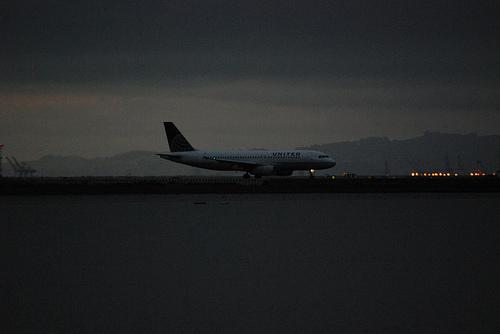Question: when airline is this?
Choices:
A. Delta.
B. United.
C. SouthWest.
D. AirTran.
Answer with the letter. Answer: B Question: where is the plane?
Choices:
A. In the air.
B. On the runway.
C. In the hanger.
D. At the gate.
Answer with the letter. Answer: B Question: why is the plane there?
Choices:
A. To land or takeoff.
B. To taxi.
C. To transport passengers.
D. For skydiving.
Answer with the letter. Answer: A Question: what time of day is it?
Choices:
A. Daytime.
B. Nighttime.
C. Dusk.
D. Dawn.
Answer with the letter. Answer: B 